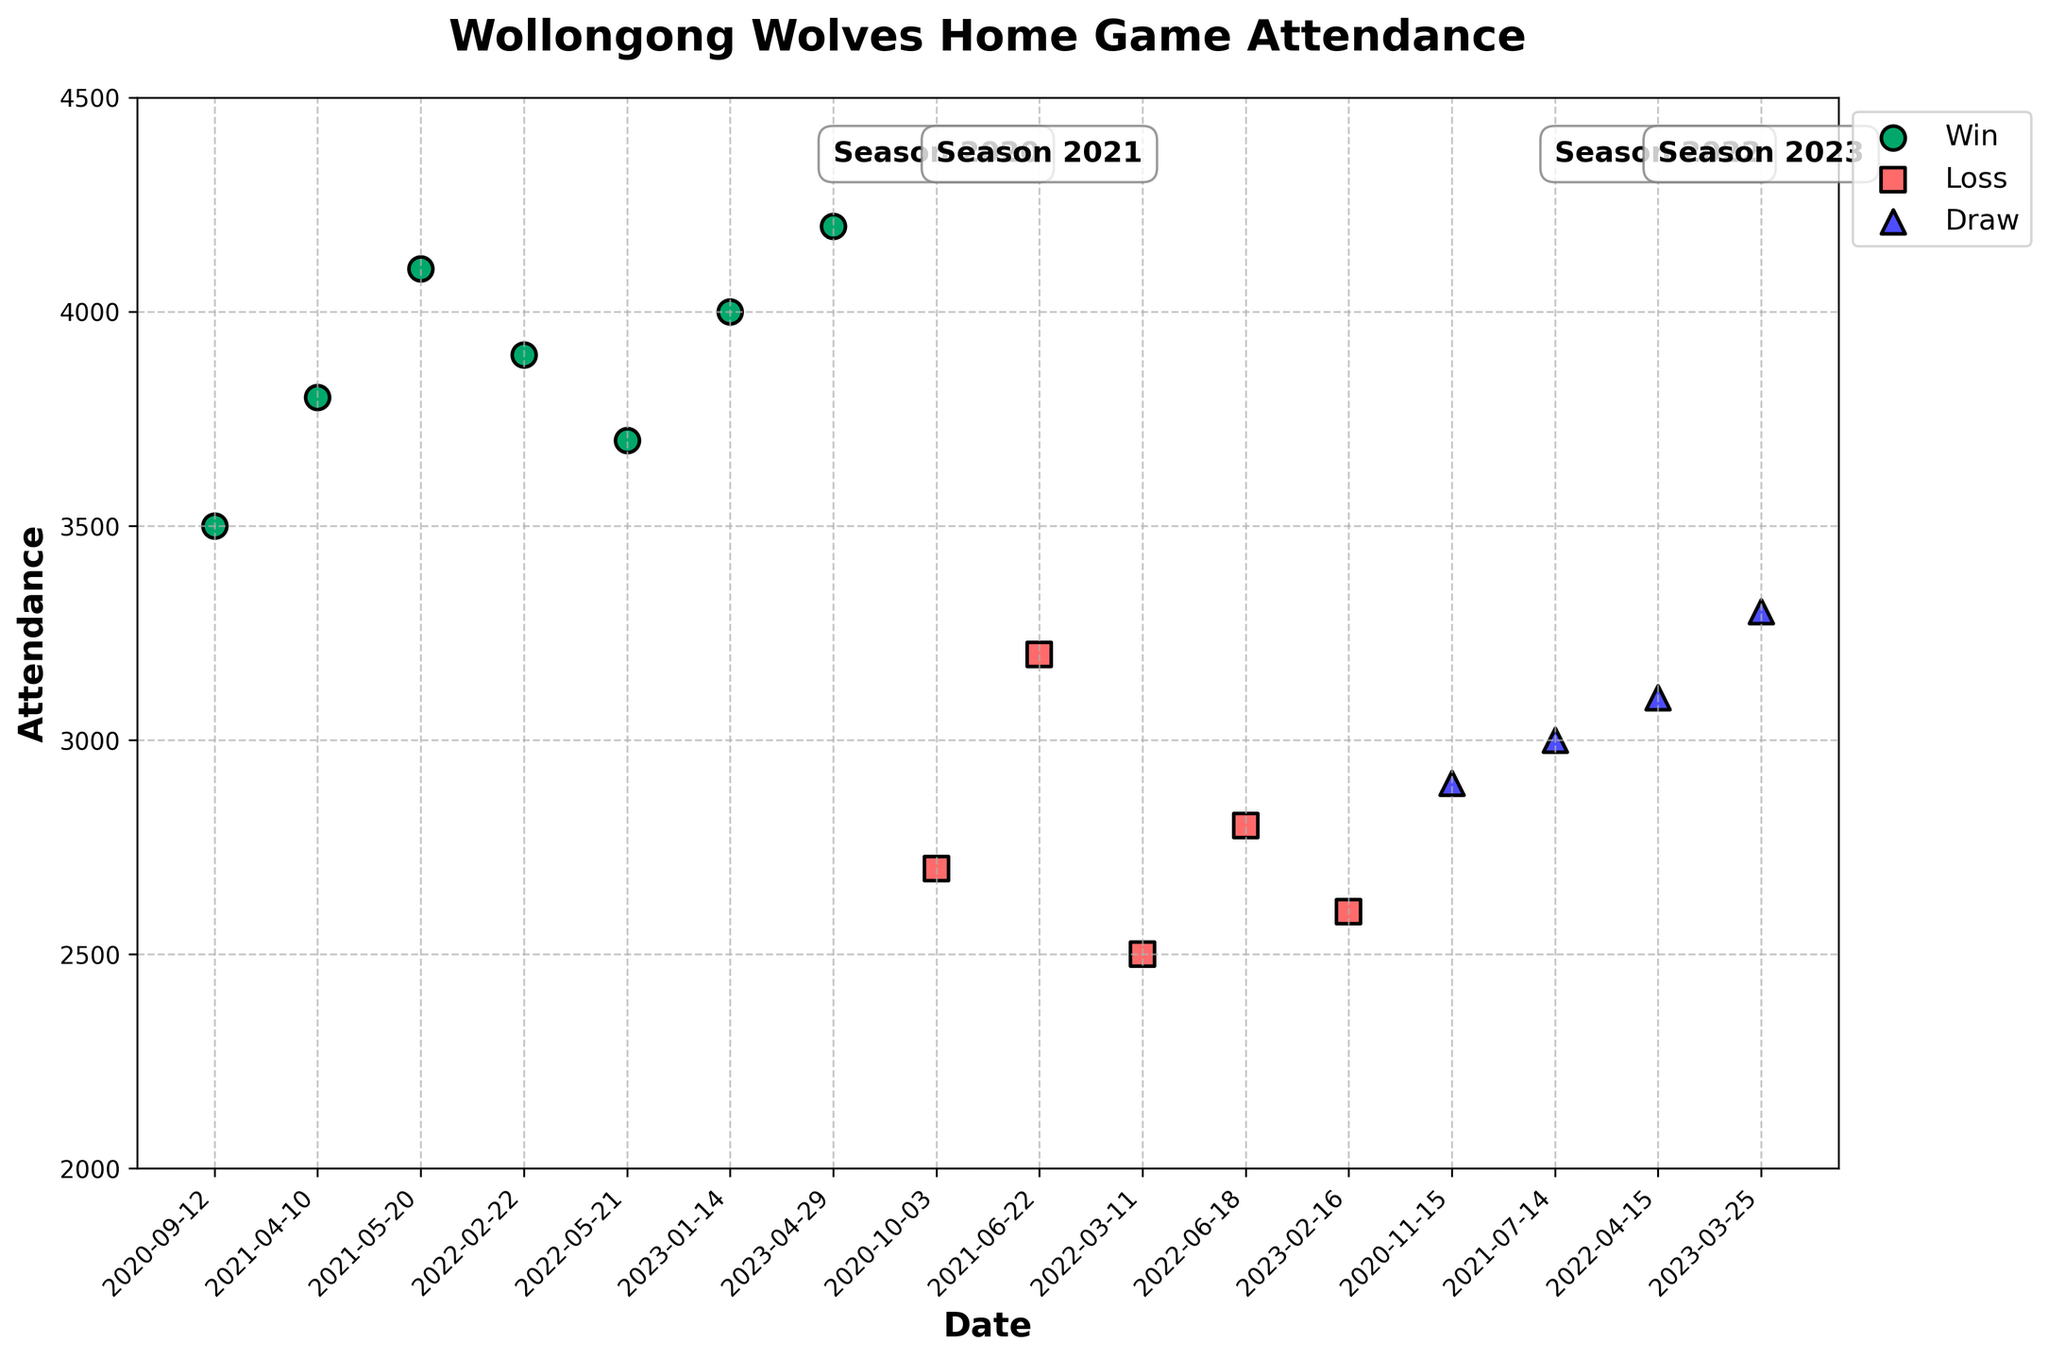Which match had the highest attendance? Look at the plot and identify which point is the highest on the y-axis. The highest point represents the match with the largest attendance.
Answer: South Coast Flame on 2023-04-29 Which season had the most wins at home games? Count the number of green dots (representing wins) in each season. Compare the counts to determine the season with the most wins.
Answer: 2021 What is the average attendance for home games in the 2023 season? Identify all attendance figures for 2023: 4000, 2600, 3300, 4200. Sum these values and divide by the number of matches (4) to find the average.
Answer: 3525 Which type of match outcome corresponds to the most data points in the plot? Count the number of dots for each match outcome: green for wins, red for losses, and blue for draws. The category with the highest count corresponds to the most data points.
Answer: Win Was there an increase or decrease in average attendance from the 2020 to 2021 season? Calculate the average attendance for each season. For 2020: (3500 + 2700 + 2900) / 3 and for 2021: (3800 + 4100 + 3200 + 3000) / 4. Compare the two averages to determine the trend.
Answer: Increase Are there any seasons where a specific type of match outcome did not occur? Check each season to see if all three types of match outcomes (win, loss, draw) are represented. Note any season(s) where a specific type is missing.
Answer: No Did the team win more home games in 2020 or 2022? Count the number of wins in each season. For 2020: 1 win, for 2022: 2 wins. Compare the counts to find which season had more wins.
Answer: 2022 Which type of match outcome generally had higher attendance? Compare the general position on the y-axis of green, red, and blue dots. Identify which color (match outcome) is generally positioned higher.
Answer: Win For which match outcome does the attendance vary the most? Examine the spread or range of attendance values for each match outcome color. Determine which one has the widest range.
Answer: Loss What was the attendance for the draw match in the 2021 season? Locate the blue triangle representing a draw in the 2021 season and read off its y-axis value.
Answer: 3000 